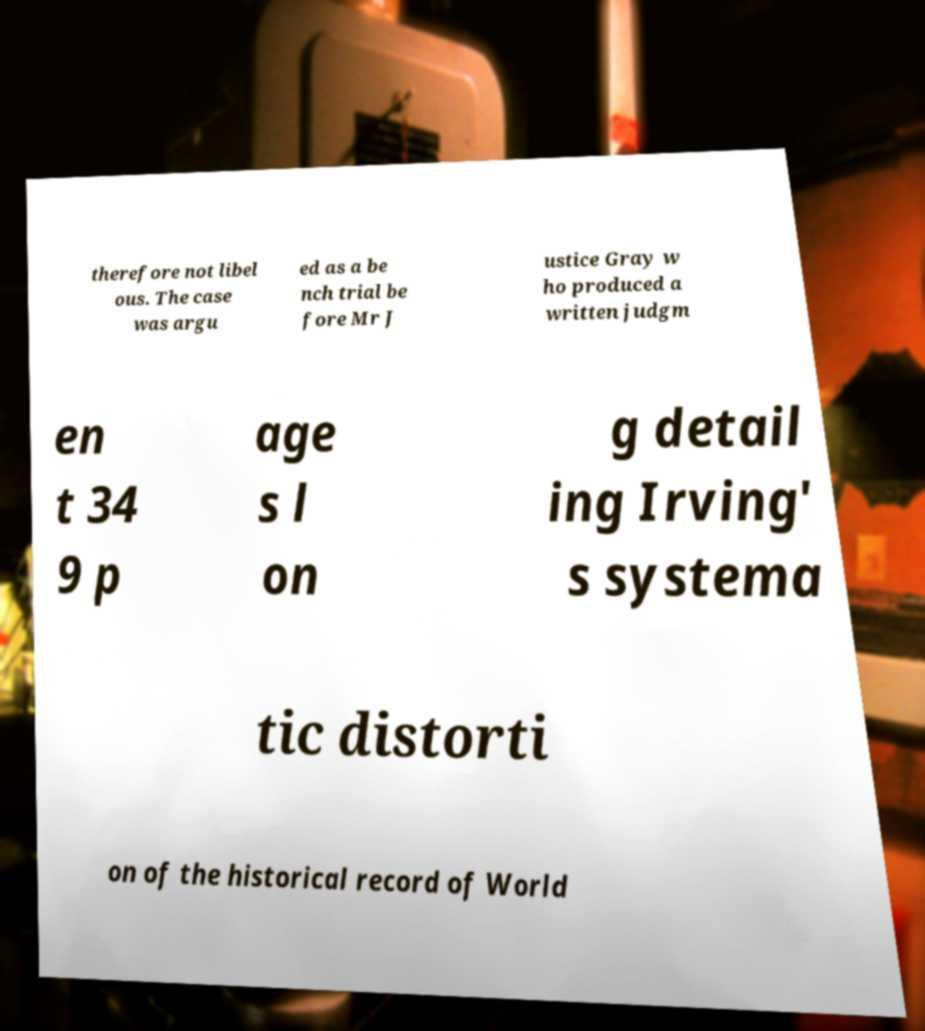Could you extract and type out the text from this image? therefore not libel ous. The case was argu ed as a be nch trial be fore Mr J ustice Gray w ho produced a written judgm en t 34 9 p age s l on g detail ing Irving' s systema tic distorti on of the historical record of World 